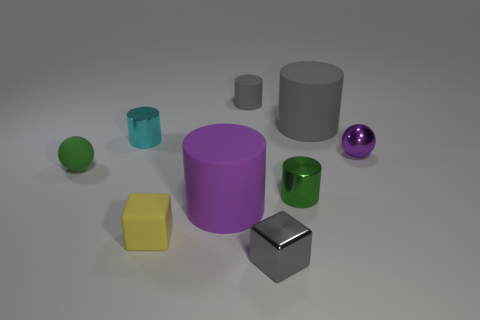The purple metal thing that is the same size as the cyan cylinder is what shape? sphere 